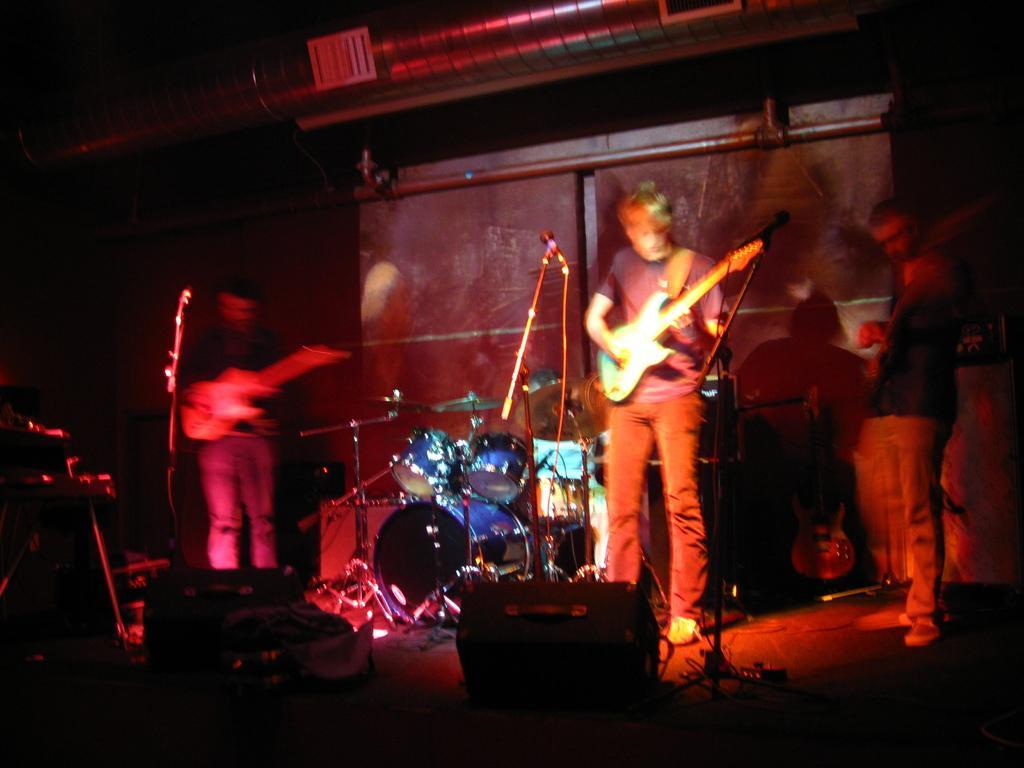Could you give a brief overview of what you see in this image? This 3 persons are standing. This 2 persons hold a guitar. In-front of them there is a mic and mic holder. This are musical instruments. 